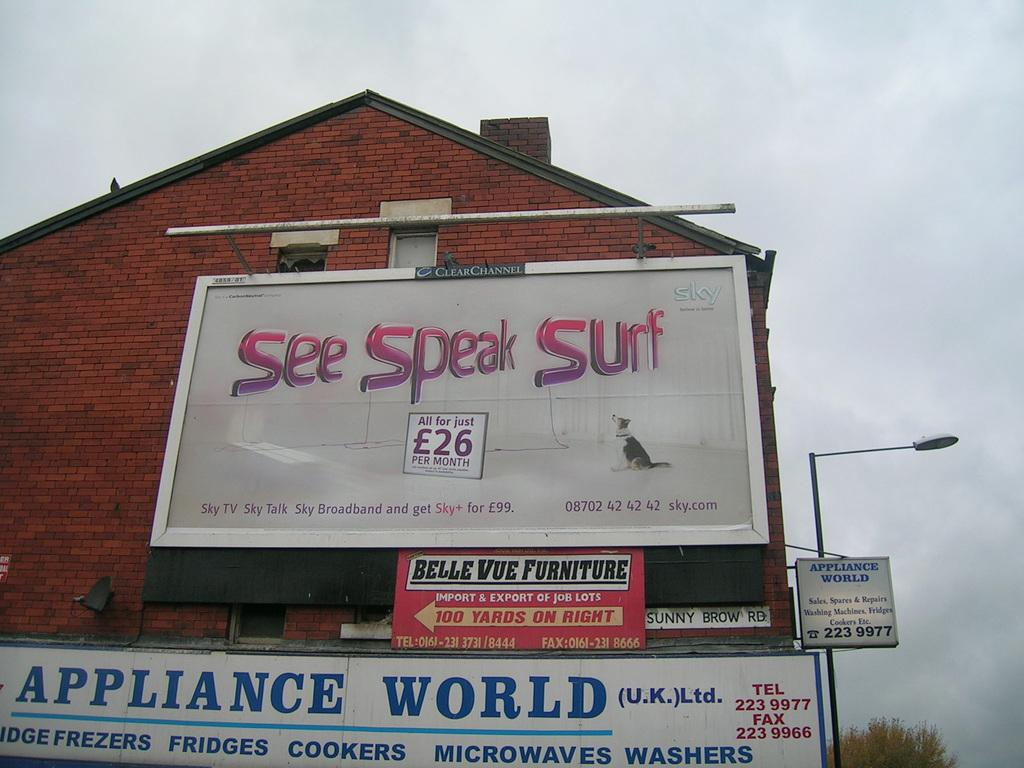<image>
Write a terse but informative summary of the picture. A bunch of signs are posted to the wall of a house including one that says see speak surf. 